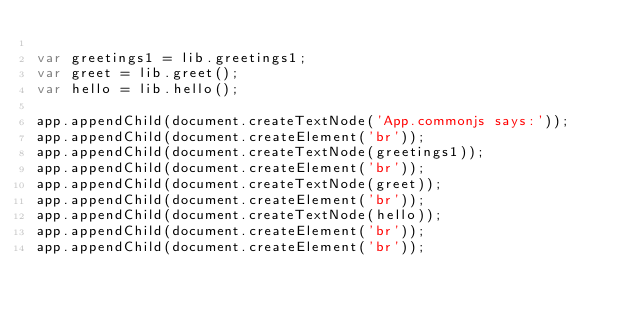Convert code to text. <code><loc_0><loc_0><loc_500><loc_500><_JavaScript_>
var greetings1 = lib.greetings1;
var greet = lib.greet();
var hello = lib.hello();

app.appendChild(document.createTextNode('App.commonjs says:'));
app.appendChild(document.createElement('br'));
app.appendChild(document.createTextNode(greetings1));
app.appendChild(document.createElement('br'));
app.appendChild(document.createTextNode(greet));
app.appendChild(document.createElement('br'));
app.appendChild(document.createTextNode(hello));
app.appendChild(document.createElement('br'));
app.appendChild(document.createElement('br'));</code> 